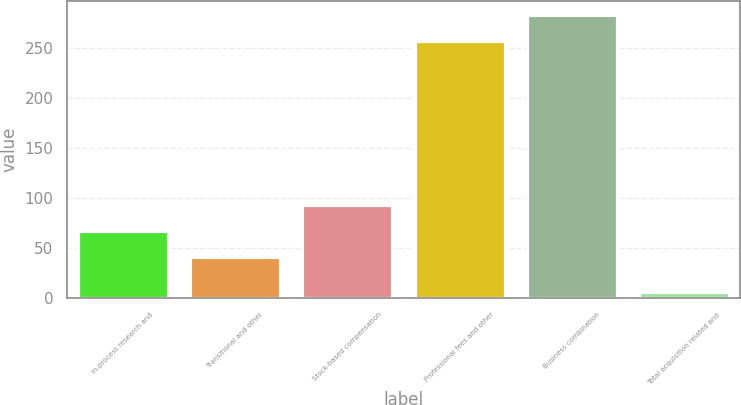<chart> <loc_0><loc_0><loc_500><loc_500><bar_chart><fcel>In-process research and<fcel>Transitional and other<fcel>Stock-based compensation<fcel>Professional fees and other<fcel>Business combination<fcel>Total acquisition related and<nl><fcel>67.1<fcel>41<fcel>93.2<fcel>257<fcel>283.1<fcel>6<nl></chart> 